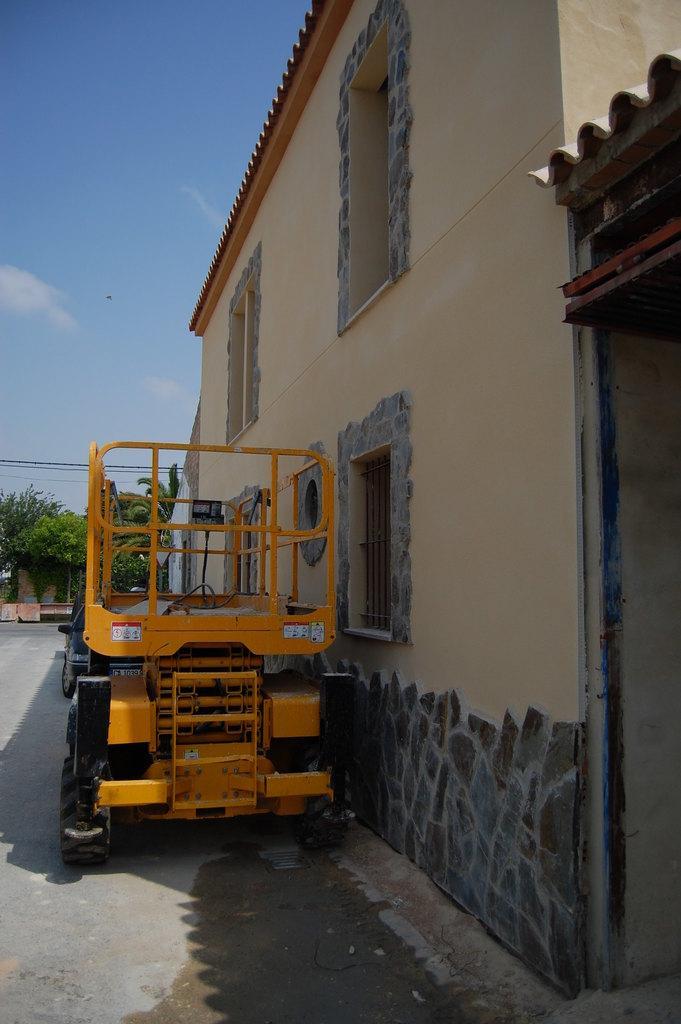Can you describe this image briefly? In this picture I can see buildings, trees and couple of vehicles parked and I can see windows and a blue cloudy sky. 